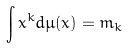Convert formula to latex. <formula><loc_0><loc_0><loc_500><loc_500>\int x ^ { k } d \mu ( x ) = m _ { k }</formula> 